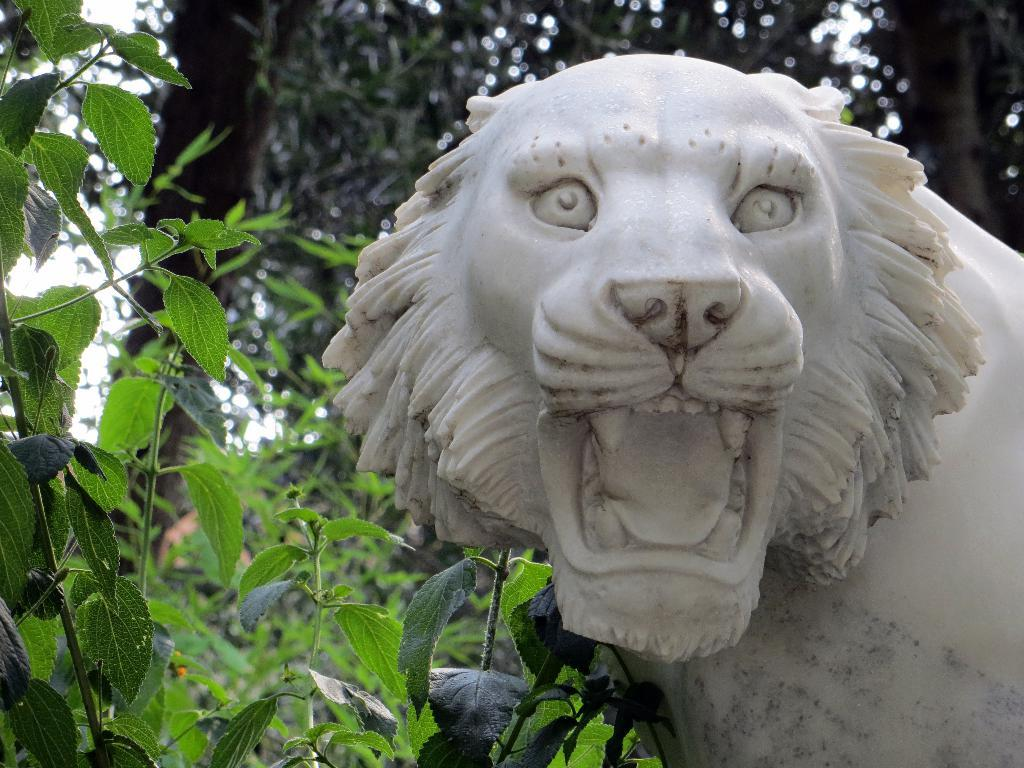What type of animal is depicted as a statue in the image? There is a statue of a lion in the image. What type of vegetation can be seen in the image? There are trees visible in the image. What is visible at the top of the image? The sky is visible at the top of the image. What color is the yak standing next to the lion statue in the image? There is no yak present in the image; it only features a statue of a lion and trees. 